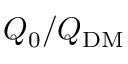<formula> <loc_0><loc_0><loc_500><loc_500>Q _ { 0 } / Q _ { D M }</formula> 